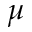<formula> <loc_0><loc_0><loc_500><loc_500>\mu</formula> 